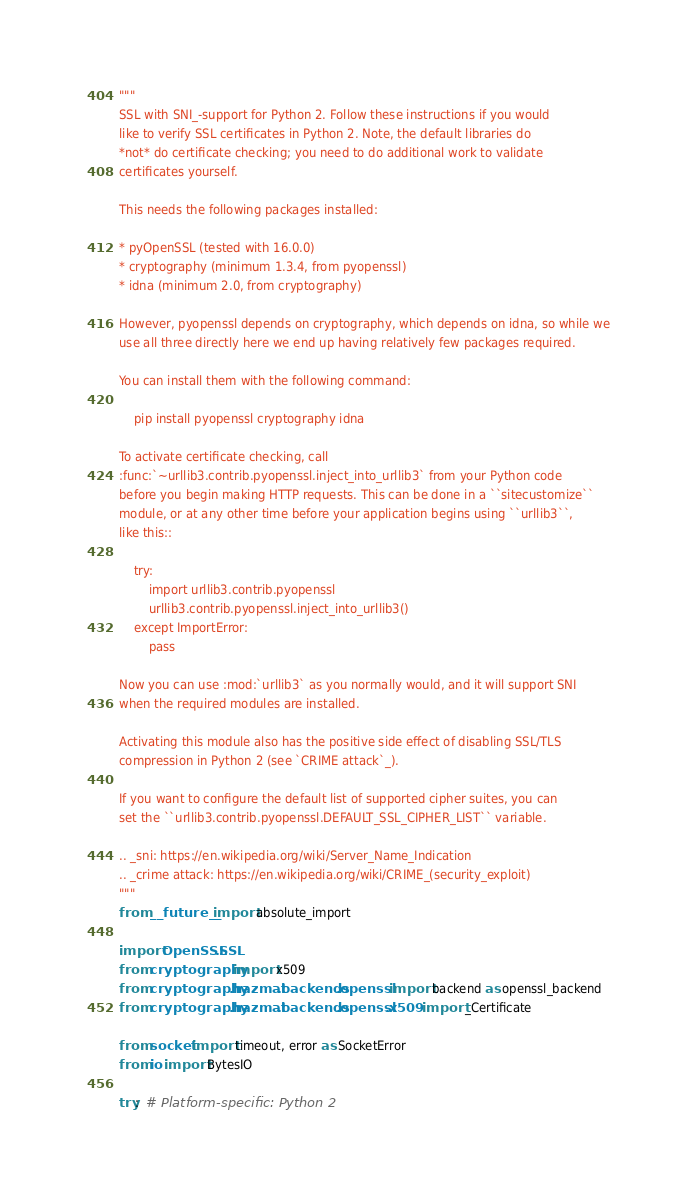Convert code to text. <code><loc_0><loc_0><loc_500><loc_500><_Python_>"""
SSL with SNI_-support for Python 2. Follow these instructions if you would
like to verify SSL certificates in Python 2. Note, the default libraries do
*not* do certificate checking; you need to do additional work to validate
certificates yourself.

This needs the following packages installed:

* pyOpenSSL (tested with 16.0.0)
* cryptography (minimum 1.3.4, from pyopenssl)
* idna (minimum 2.0, from cryptography)

However, pyopenssl depends on cryptography, which depends on idna, so while we
use all three directly here we end up having relatively few packages required.

You can install them with the following command:

    pip install pyopenssl cryptography idna

To activate certificate checking, call
:func:`~urllib3.contrib.pyopenssl.inject_into_urllib3` from your Python code
before you begin making HTTP requests. This can be done in a ``sitecustomize``
module, or at any other time before your application begins using ``urllib3``,
like this::

    try:
        import urllib3.contrib.pyopenssl
        urllib3.contrib.pyopenssl.inject_into_urllib3()
    except ImportError:
        pass

Now you can use :mod:`urllib3` as you normally would, and it will support SNI
when the required modules are installed.

Activating this module also has the positive side effect of disabling SSL/TLS
compression in Python 2 (see `CRIME attack`_).

If you want to configure the default list of supported cipher suites, you can
set the ``urllib3.contrib.pyopenssl.DEFAULT_SSL_CIPHER_LIST`` variable.

.. _sni: https://en.wikipedia.org/wiki/Server_Name_Indication
.. _crime attack: https://en.wikipedia.org/wiki/CRIME_(security_exploit)
"""
from __future__ import absolute_import

import OpenSSL.SSL
from cryptography import x509
from cryptography.hazmat.backends.openssl import backend as openssl_backend
from cryptography.hazmat.backends.openssl.x509 import _Certificate

from socket import timeout, error as SocketError
from io import BytesIO

try:  # Platform-specific: Python 2</code> 